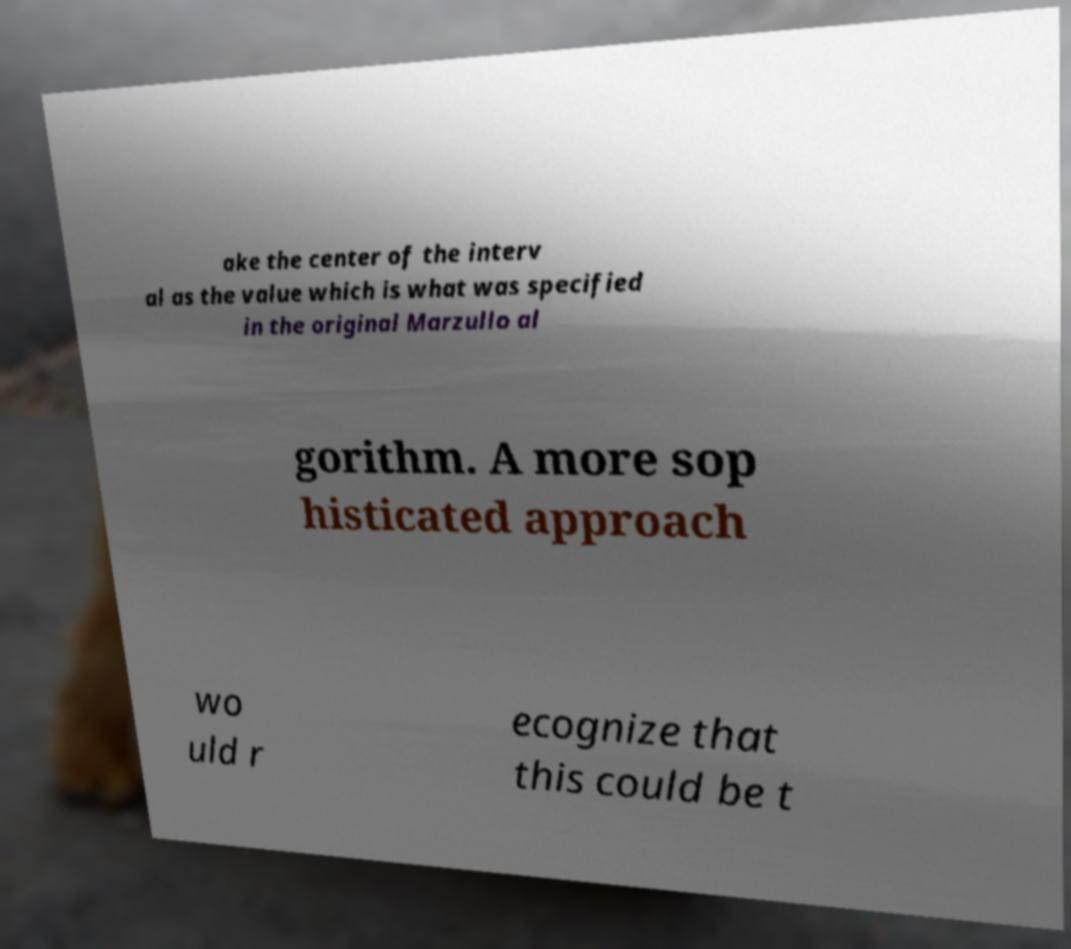Please read and relay the text visible in this image. What does it say? ake the center of the interv al as the value which is what was specified in the original Marzullo al gorithm. A more sop histicated approach wo uld r ecognize that this could be t 